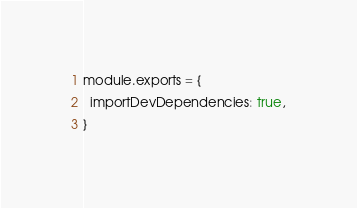Convert code to text. <code><loc_0><loc_0><loc_500><loc_500><_JavaScript_>module.exports = {
  importDevDependencies: true,
}
</code> 